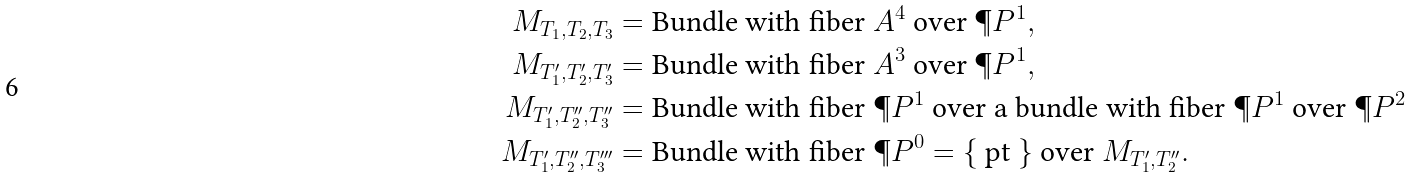<formula> <loc_0><loc_0><loc_500><loc_500>M _ { T _ { 1 } , T _ { 2 } , T _ { 3 } } & = \text {Bundle with fiber } \AA A ^ { 4 } \text { over } \P P ^ { 1 } , \\ M _ { T ^ { \prime } _ { 1 } , T ^ { \prime } _ { 2 } , T ^ { \prime } _ { 3 } } & = \text {Bundle with fiber } \AA A ^ { 3 } \text { over } \P P ^ { 1 } , \\ M _ { T ^ { \prime } _ { 1 } , T ^ { \prime \prime } _ { 2 } , T ^ { \prime \prime } _ { 3 } } & = \text {Bundle with fiber } \P P ^ { 1 } \text { over a bundle with fiber } \P P ^ { 1 } \text { over } \P P ^ { 2 } \\ M _ { T ^ { \prime } _ { 1 } , T ^ { \prime \prime } _ { 2 } , T ^ { \prime \prime \prime } _ { 3 } } & = \text {Bundle with fiber } \P P ^ { 0 } = \{ \text { pt } \} \text { over } M _ { T ^ { \prime } _ { 1 } , T ^ { \prime \prime } _ { 2 } } .</formula> 